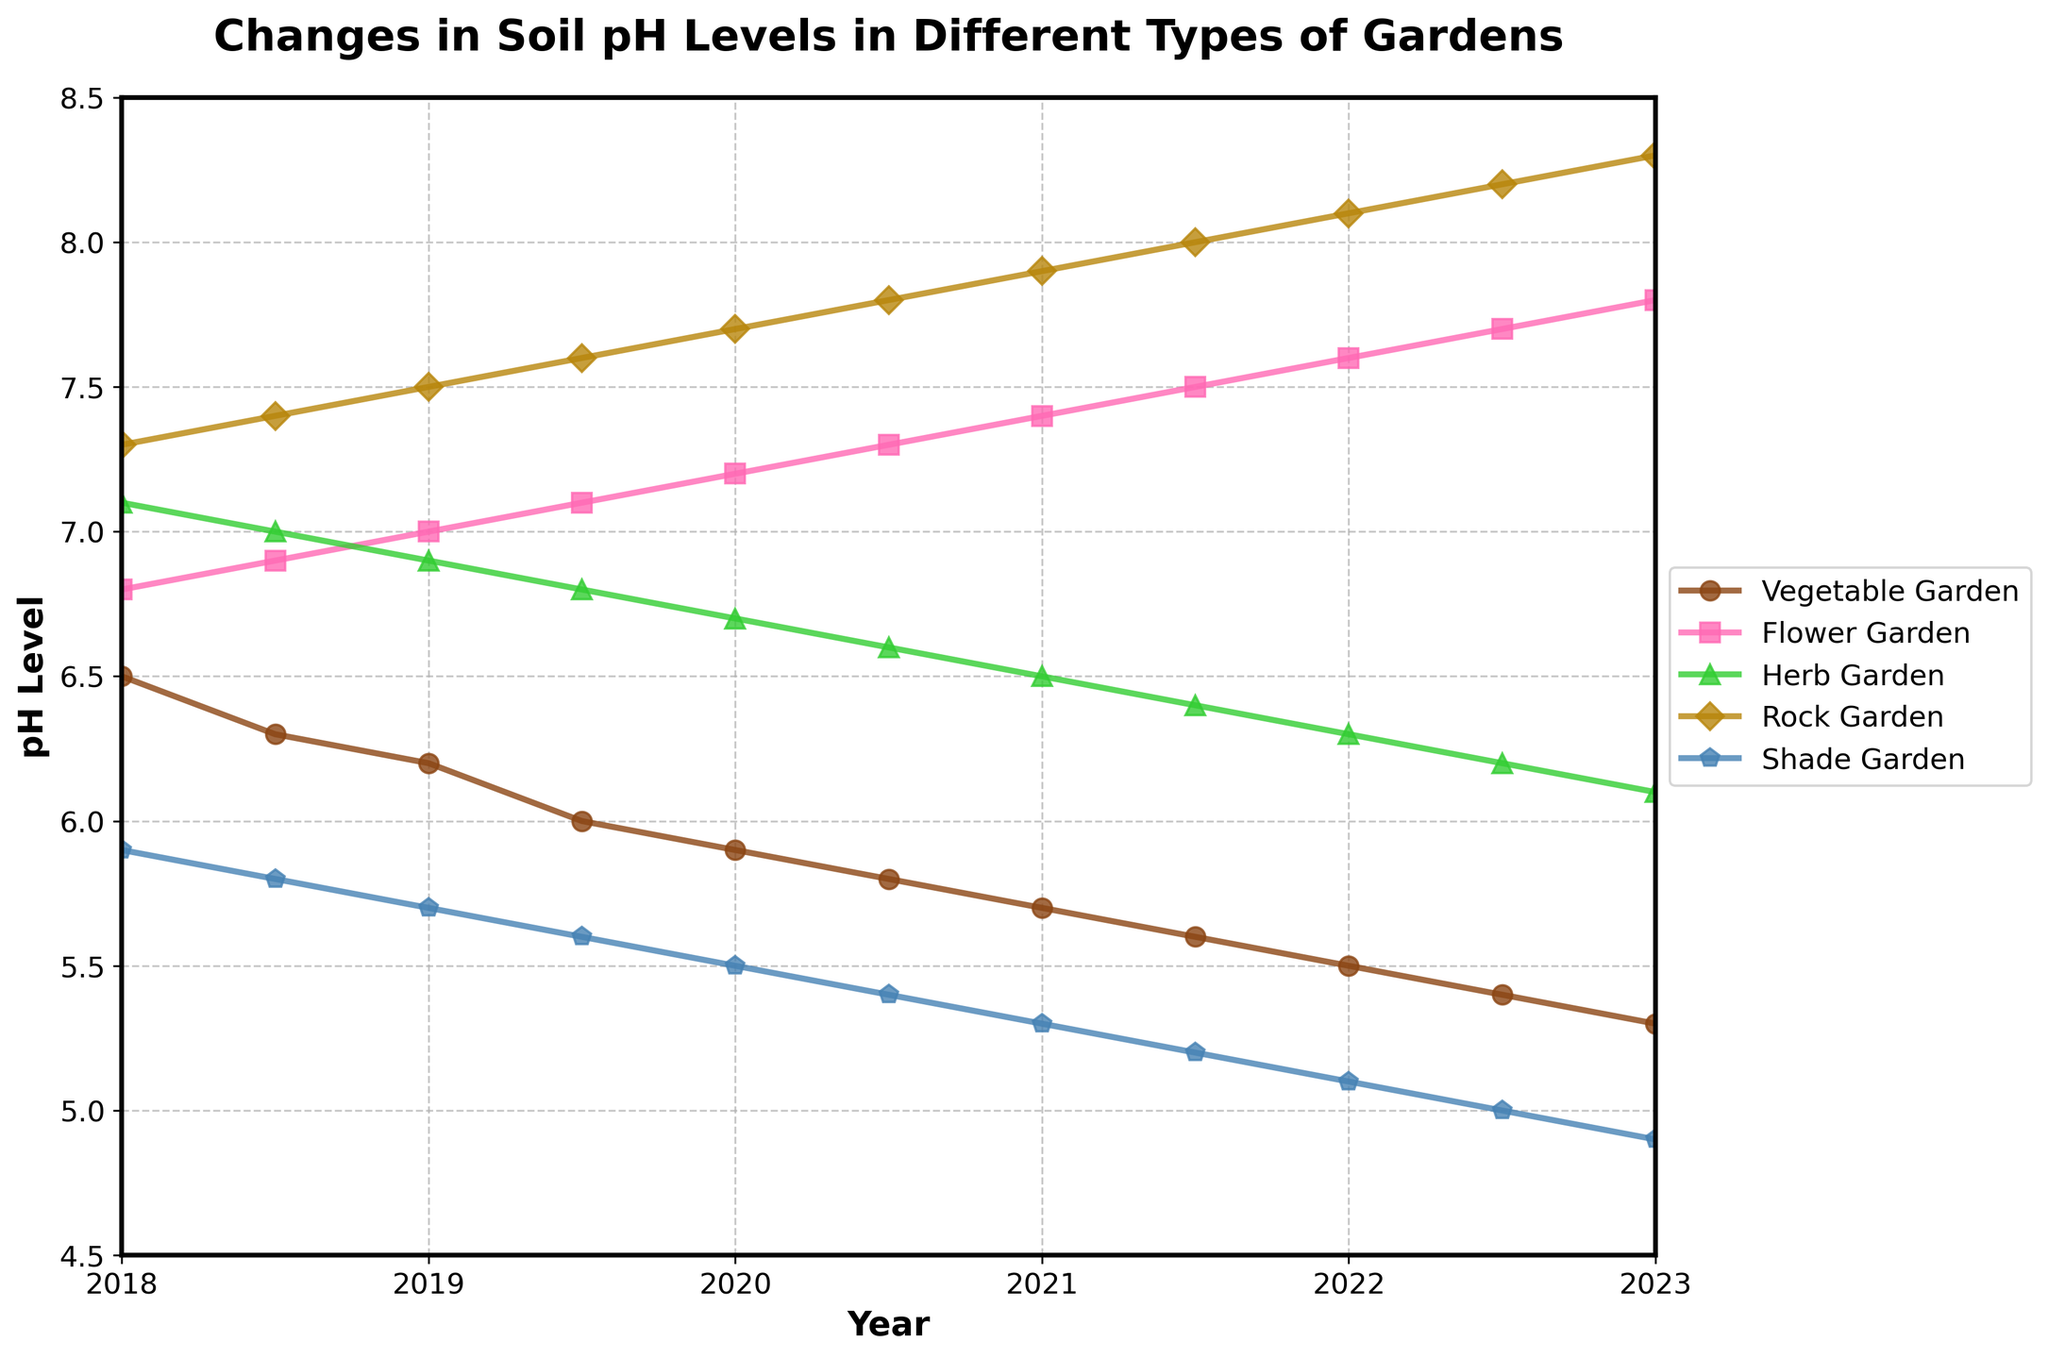What's the trend of soil pH levels in the Vegetable Garden from 2018 to 2023? The soil pH levels in the Vegetable Garden show a decreasing trend. Starting from 6.5 in 2018 and continually decreasing to 5.3 in 2023.
Answer: Decreasing Which type of garden has the highest soil pH level in 2023? By looking at the chart, the Rock Garden has the highest soil pH level in 2023, which is 8.3.
Answer: Rock Garden Compare the soil pH levels of the Flower Garden and the Shade Garden in 2019. Which is higher? In 2019, the Flower Garden has a pH level of 7.0, and the Shade Garden has a pH level of 5.7. Therefore, the pH level of the Flower Garden is higher.
Answer: Flower Garden What is the average soil pH level in the Herb Garden over the 5 years? The yearly pH levels in the Herb Garden are 7.1, 7.0, 6.9, 6.8, 6.7, 6.6, 6.5, 6.4, 6.3, 6.2, and 6.1. Summing them up yields 74.6. There are 11 values, so the average is 74.6/11 = 6.78.
Answer: 6.78 Which garden has the most stable pH level, defined as having the least change in pH levels over the years? By comparing the changes in pH levels for each garden from 2018 to 2023, the Flower Garden shows the smallest change from 6.8 to 7.8, a change of 1.0. Other gardens show larger changes.
Answer: Flower Garden What two years have the same pH level in the Shade Garden, and what is that pH level? By examining the plot for the Shade Garden, the pH levels in 2018 and 2020 are both 5.9.
Answer: 2018 and 2020, 5.9 In which year does the Rock Garden first reach a pH level of 8.0? By following the Rock Garden’s curve, the first year it reaches a pH level of 8.0 is in 2021.5.
Answer: 2021.5 By how much does the pH level in the Shade Garden change from 2018 to 2023, and is it an increase or decrease? The pH in the Shade Garden in 2018 is 5.9 and in 2023 is 4.9. The change is 5.9 - 4.9 = 1.0, and it is a decrease.
Answer: Decrease by 1.0 Which garden recorded the highest increase in soil pH from 2018 to 2023? By comparing the pH levels in 2018 and 2023 for all gardens, the Rock Garden shows an increase from 7.3 in 2018 to 8.3 in 2023, which is a 1.0 increase.
Answer: Rock Garden 